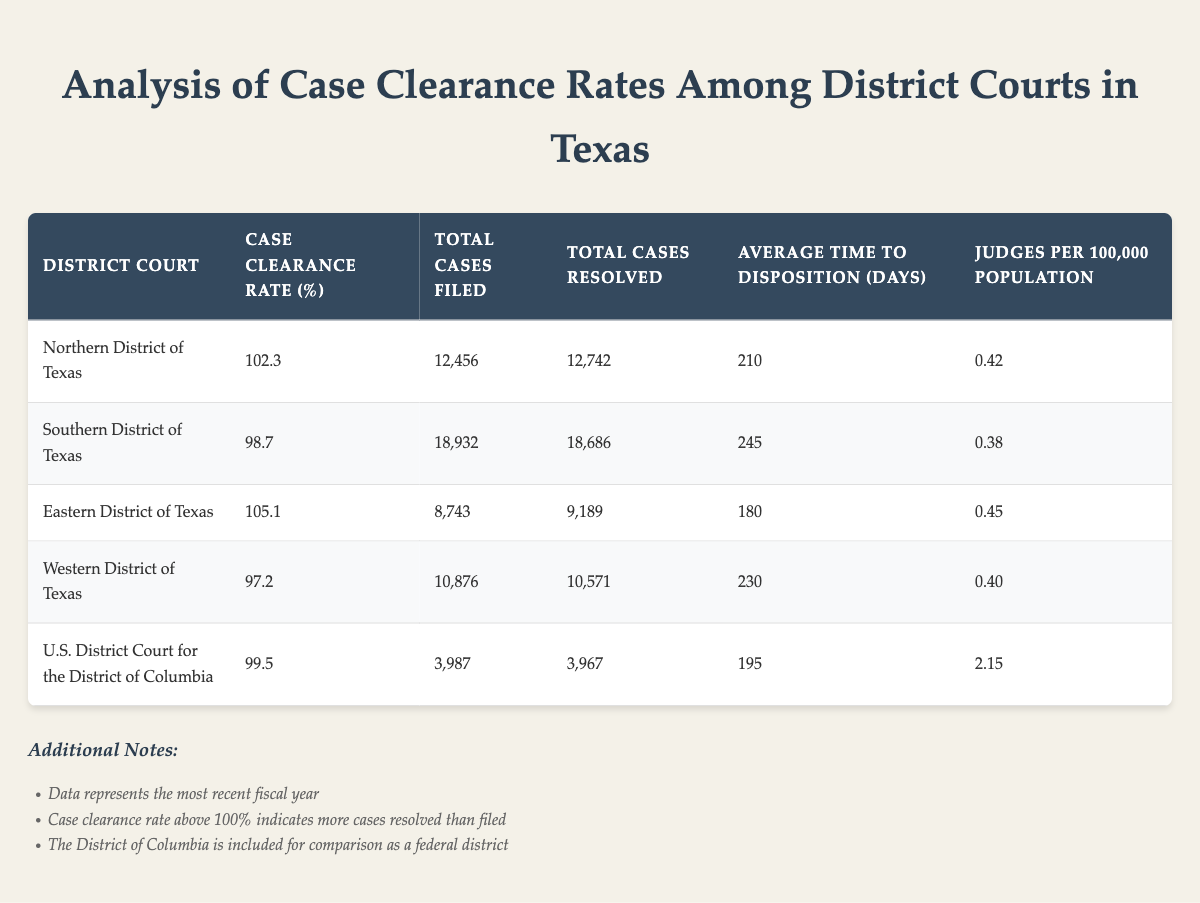What is the case clearance rate for the Northern District of Texas? The case clearance rate is listed directly in the table under the corresponding district, which shows 102.3%.
Answer: 102.3% Which district has the highest average time to disposition in days? In the table, the average time to disposition for each district is compared. The Southern District of Texas shows the highest time at 245 days.
Answer: Southern District of Texas How many total cases were resolved in the Eastern District of Texas? The "Total Cases Resolved" column shows that 9,189 cases were resolved in the Eastern District of Texas.
Answer: 9,189 Is the case clearance rate for the Western District of Texas above 100%? By referencing the case clearance rate for the Western District of Texas, which is 97.2%, it is confirmed that this rate is not above 100%.
Answer: No What is the difference in total cases filed between the Southern District of Texas and the Western District of Texas? The Southern District of Texas has 18,932 total cases filed while the Western District of Texas has 10,876. The difference is calculated as 18,932 - 10,876 = 8,056.
Answer: 8,056 What is the average case clearance rate of all the Texas district courts? To find the average, we sum up the case clearance rates: (102.3 + 98.7 + 105.1 + 97.2) / 4 = 100.83. The average case clearance rate for the four Texas districts is then 100.83%.
Answer: 100.83% Which district has the most judges per 100,000 population? In the table, the judges per 100,000 population for each district is shown. The U.S. District Court for the District of Columbia has the highest number at 2.15.
Answer: U.S. District Court for the District of Columbia What is the total number of cases filed across all Texas district courts? The total cases filed is obtained by summing the total from each district: 12,456 + 18,932 + 8,743 + 10,876 = 50,007 total cases filed across Texas district courts.
Answer: 50,007 Is the average time to disposition in the Eastern District of Texas shorter than in the Southern District of Texas? The average time to disposition for the Eastern District is 180 days, while for the Southern District, it is 245 days. Since 180 is less than 245, the average disposition time is shorter in the Eastern District.
Answer: Yes 